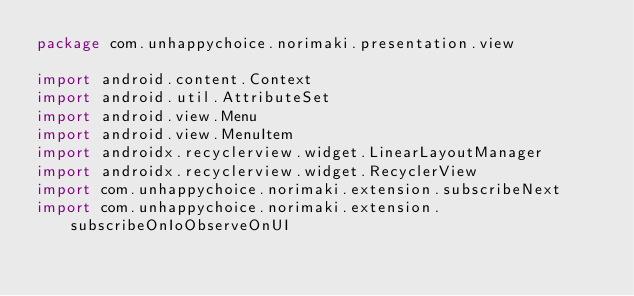<code> <loc_0><loc_0><loc_500><loc_500><_Kotlin_>package com.unhappychoice.norimaki.presentation.view

import android.content.Context
import android.util.AttributeSet
import android.view.Menu
import android.view.MenuItem
import androidx.recyclerview.widget.LinearLayoutManager
import androidx.recyclerview.widget.RecyclerView
import com.unhappychoice.norimaki.extension.subscribeNext
import com.unhappychoice.norimaki.extension.subscribeOnIoObserveOnUI</code> 